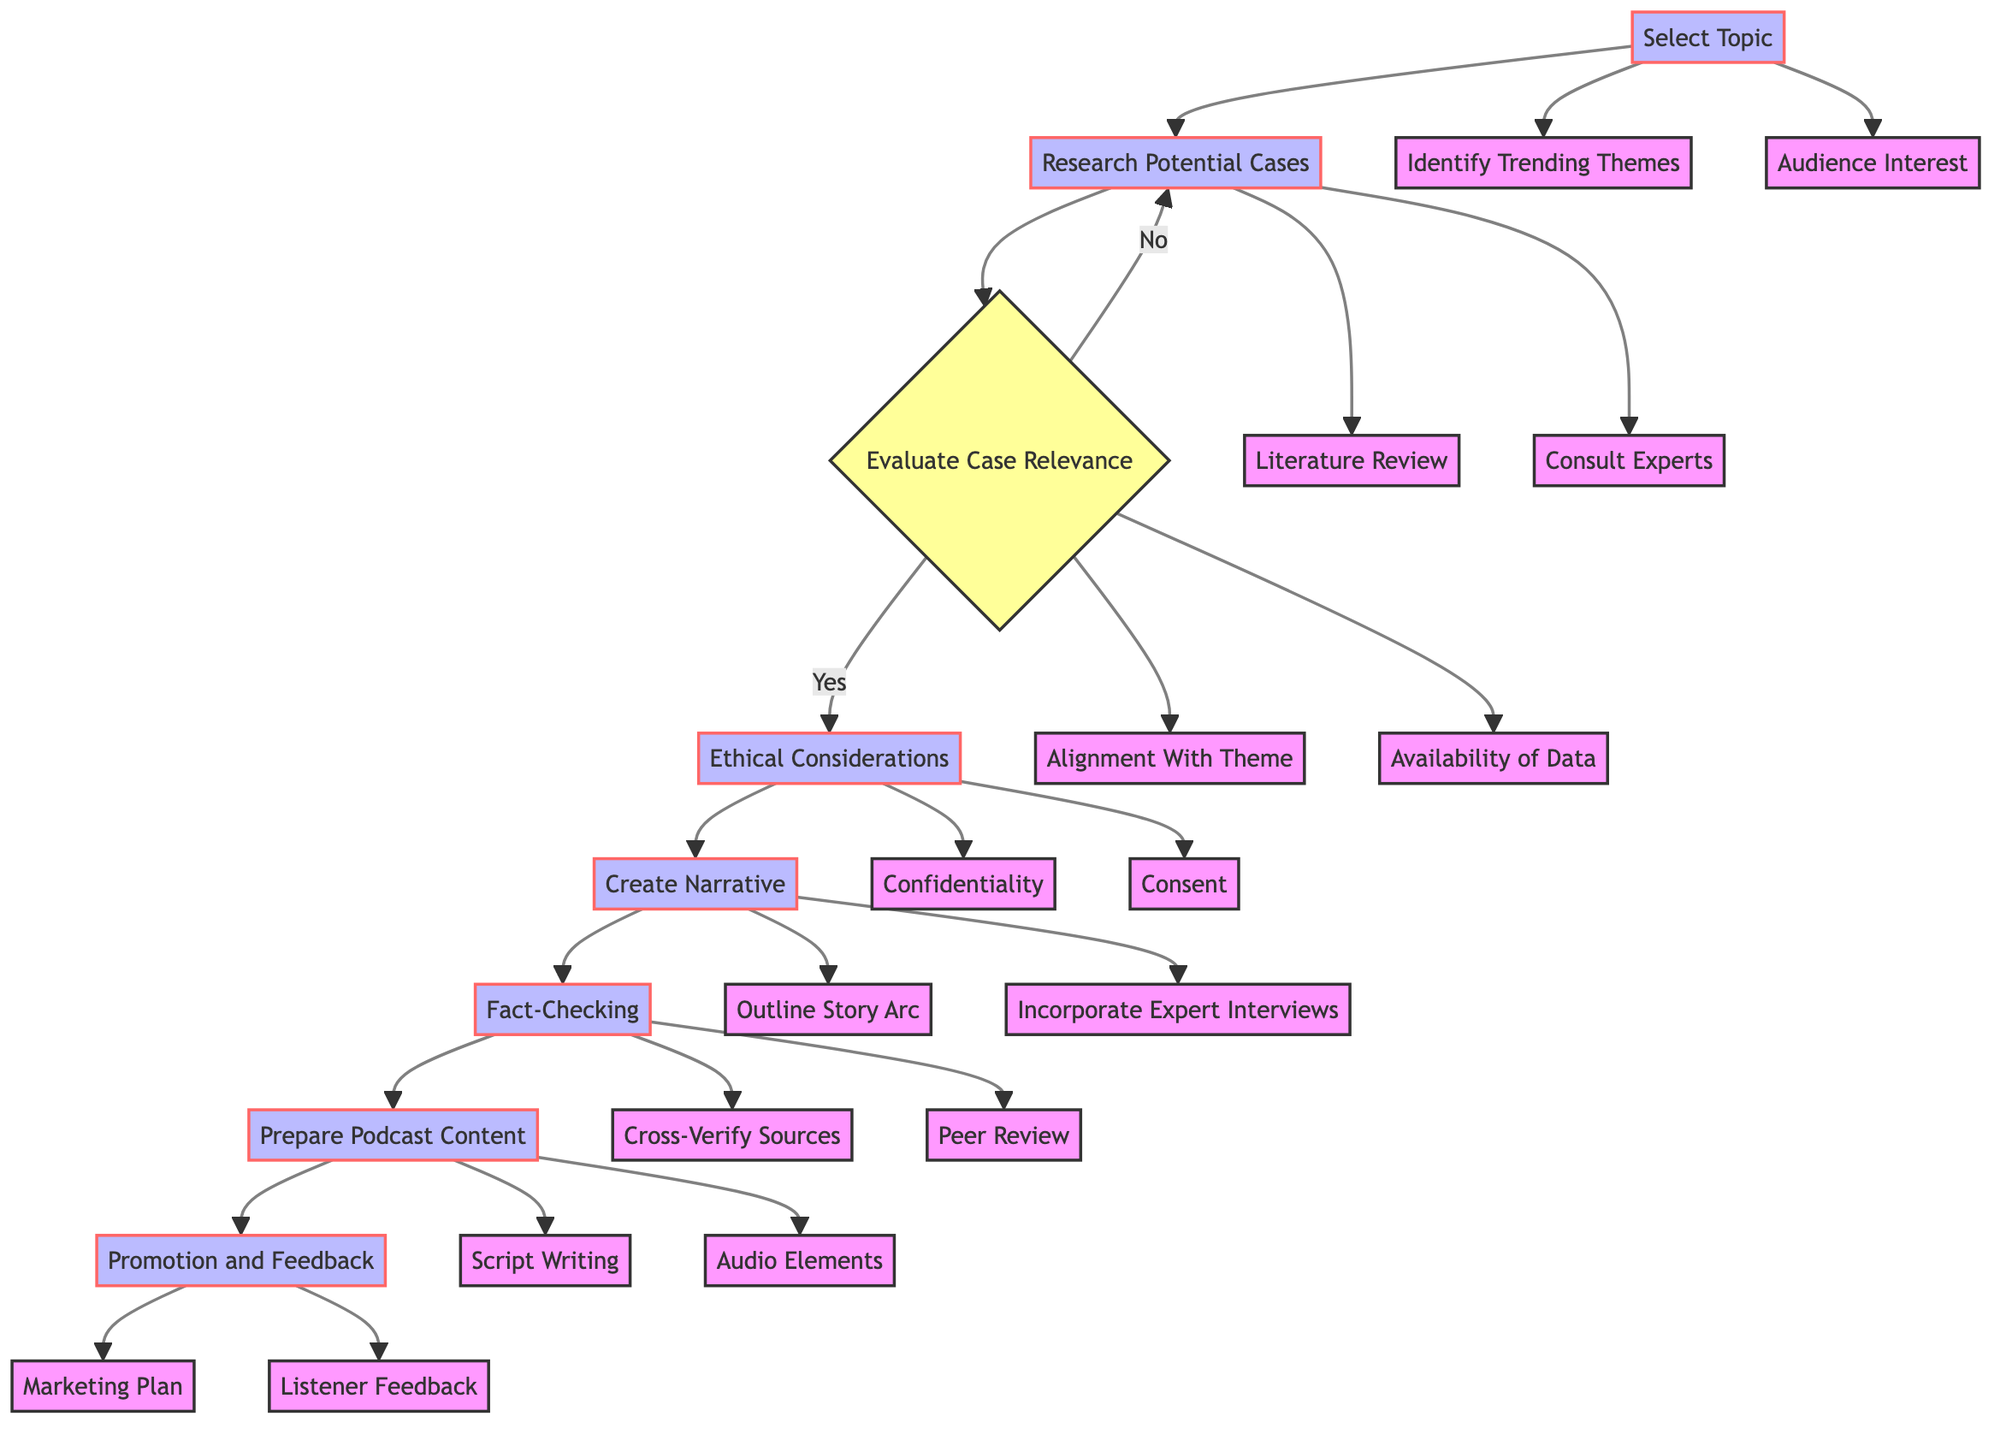What is the first step in the procedure? The diagram indicates that the first step is "Select Topic," which initiates the flow of the process.
Answer: Select Topic How many branches stem from the "Select Topic" node? The "Select Topic" node has two branches: "Identify Trending Themes" and "Audience Interest."
Answer: 2 What follows after "Evaluate Case Relevance" if the case is relevant? If the case is relevant (marked by "Yes"), the next step in the flow is "Ethical Considerations."
Answer: Ethical Considerations What are the two components involved in "Create Narrative"? The "Create Narrative" node branches into "Outline Story Arc" and "Incorporate Expert Interviews."
Answer: Outline Story Arc and Incorporate Expert Interviews What does the process culminate in? The final step of the process is "Promotion and Feedback," which indicates the conclusion of the entire procedure.
Answer: Promotion and Feedback If "Consult Experts" is selected during the research phase, what is the previous node? The previous node before "Consult Experts" is "Research Potential Cases," as it is the direct predecessor in the flowchart.
Answer: Research Potential Cases Which node comes after "Fact-Checking"? Following "Fact-Checking," the next step in the process is "Prepare Podcast Content."
Answer: Prepare Podcast Content What must be ensured in "Ethical Considerations"? "Ethical Considerations" includes ensuring "Confidentiality" and obtaining "Consent," both of which are essential for ethical compliance.
Answer: Confidentiality and Consent How many decisions are present in the flowchart? There is one decision node in the flowchart, which is "Evaluate Case Relevance," determining the next steps based on case relevance.
Answer: 1 